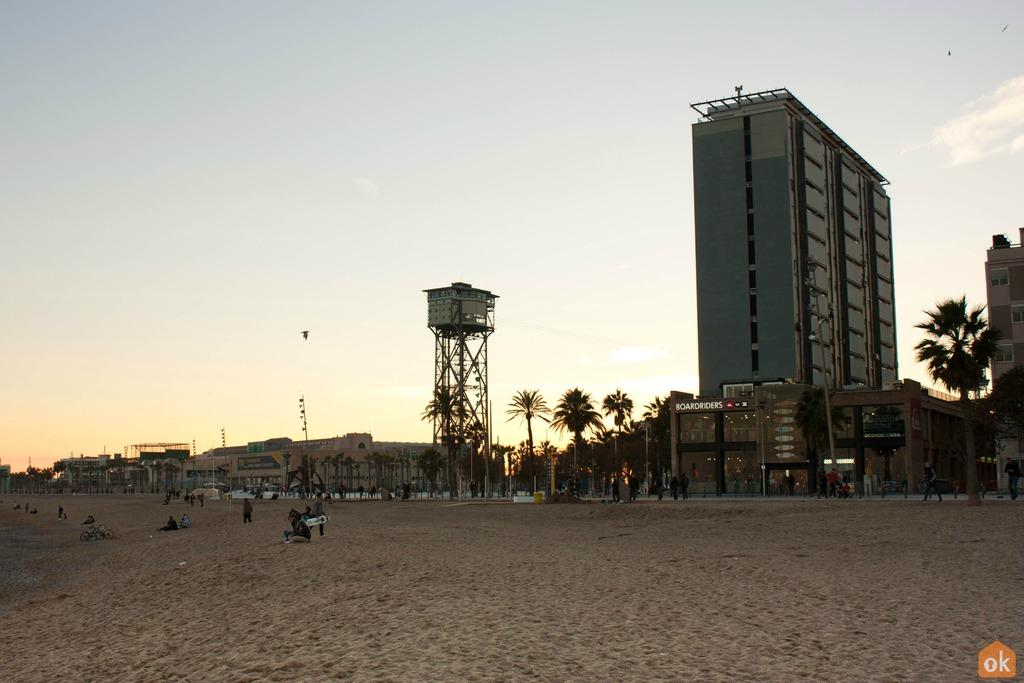What type of structures can be seen in the image? There are buildings and a tower in the image. What is the condition of the sky in the image? The sky is cloudy in the image. Can you describe the people in the image? There are people standing and seated in the image. What else can be seen in the image besides buildings and people? There are trees in the image, and birds are flying in the sky. What color is the vest worn by the mother in the image? There is no mother or vest present in the image. What suggestion is being made by the people in the image? The image does not depict any suggestions being made; it simply shows people standing and seated. 